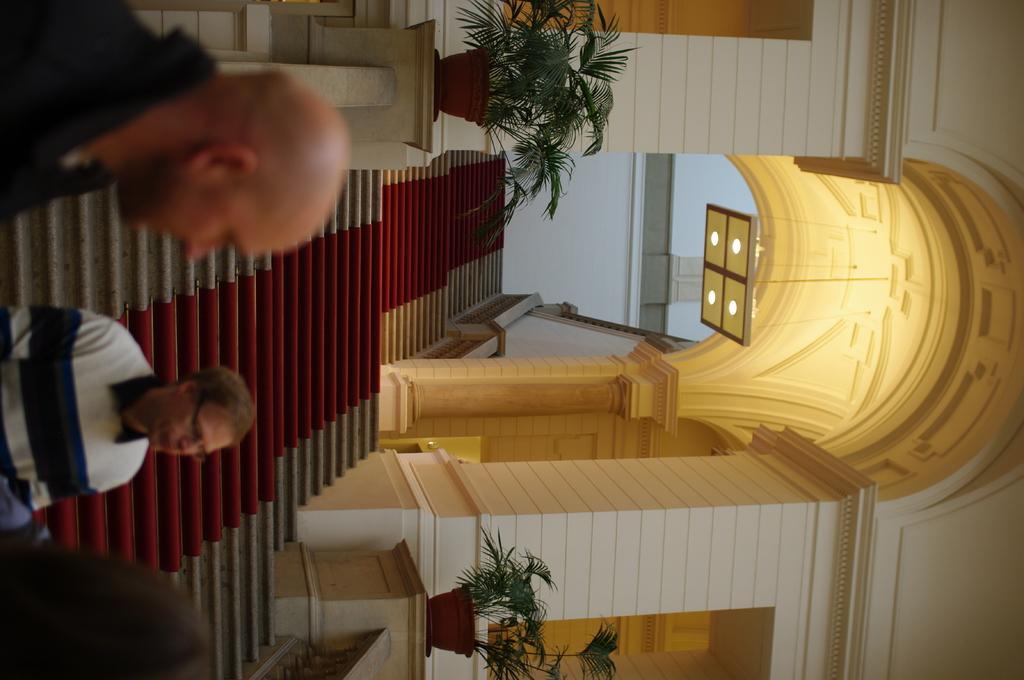How would you summarize this image in a sentence or two? In this image, there are a few people. We can see some stairs and plants in pots. We can see the railing and an arch. We can also see an object attached to the roof. We can also see the wall. 